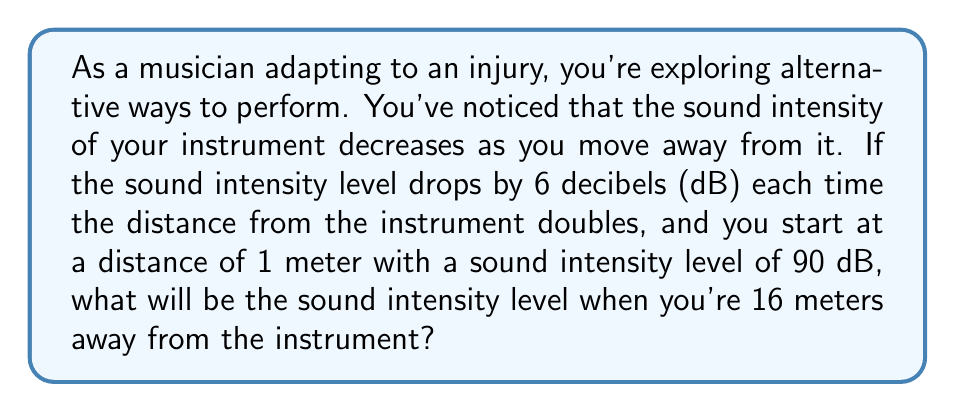Could you help me with this problem? Let's approach this step-by-step:

1) First, we need to understand the relationship between distance and sound intensity level. The question states that the level drops by 6 dB each time the distance doubles.

2) We start at 1 meter and need to find the level at 16 meters. Let's see how many times we need to double the distance to get from 1 to 16:
   1 → 2 → 4 → 8 → 16
   This is 4 doublings.

3) Each doubling reduces the sound intensity level by 6 dB. So for 4 doublings, we need to subtract:
   $$ 4 \times 6 \text{ dB} = 24 \text{ dB} $$

4) We started with a sound intensity level of 90 dB at 1 meter. So at 16 meters, the level will be:
   $$ 90 \text{ dB} - 24 \text{ dB} = 66 \text{ dB} $$

5) We can verify this using the logarithmic formula for sound intensity level:
   $$ L = L_0 - 10 \log_{10}\left(\frac{r^2}{r_0^2}\right) $$
   Where $L$ is the new level, $L_0$ is the initial level, $r$ is the new distance, and $r_0$ is the initial distance.

6) Plugging in our values:
   $$ L = 90 - 10 \log_{10}\left(\frac{16^2}{1^2}\right) = 90 - 10 \log_{10}(256) = 90 - 24 = 66 \text{ dB} $$

This confirms our step-by-step calculation.
Answer: The sound intensity level at 16 meters away from the instrument will be 66 dB. 